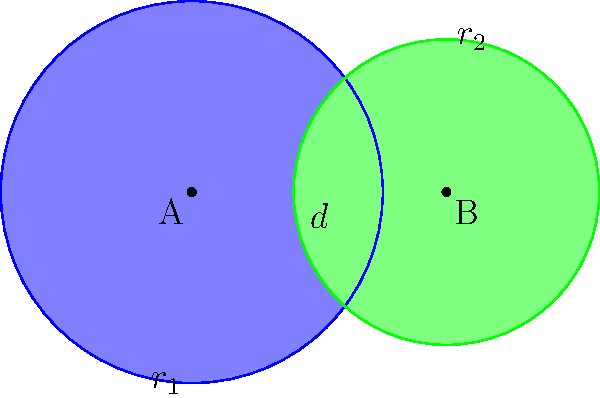Consider two overlapping circles with centers A and B, radii $r_1 = 1.5$ and $r_2 = 1.2$ respectively, and a distance $d = 2$ between their centers. Using concepts from set theory and geometry, calculate the area of the region where the circles intersect. How might this problem relate to Venn diagrams used in logical reasoning? Let's approach this step-by-step:

1) First, we need to find the height of the triangle formed by the intersection points and the line connecting the centers. We can use the formula:

   $$h = \sqrt{r_1^2 - (\frac{d^2 + r_1^2 - r_2^2}{2d})^2}$$

2) Substituting the values:

   $$h = \sqrt{1.5^2 - (\frac{2^2 + 1.5^2 - 1.2^2}{2(2)})^2} \approx 0.7794$$

3) The area of intersection is given by:

   $$A = r_1^2 \arccos(\frac{d^2 + r_1^2 - r_2^2}{2dr_1}) + r_2^2 \arccos(\frac{d^2 - r_1^2 + r_2^2}{2dr_2}) - dh$$

4) Substituting the values:

   $$A = 1.5^2 \arccos(\frac{2^2 + 1.5^2 - 1.2^2}{2(2)(1.5)}) + 1.2^2 \arccos(\frac{2^2 - 1.5^2 + 1.2^2}{2(2)(1.2)}) - 2(0.7794)$$

5) Calculating:

   $$A \approx 0.7854$$

This problem relates to Venn diagrams and logical reasoning in philosophy by representing the intersection of two sets. In set theory, this intersection would represent elements common to both sets, which is a fundamental concept in logical reasoning and argumentation.
Answer: $0.7854$ square units 